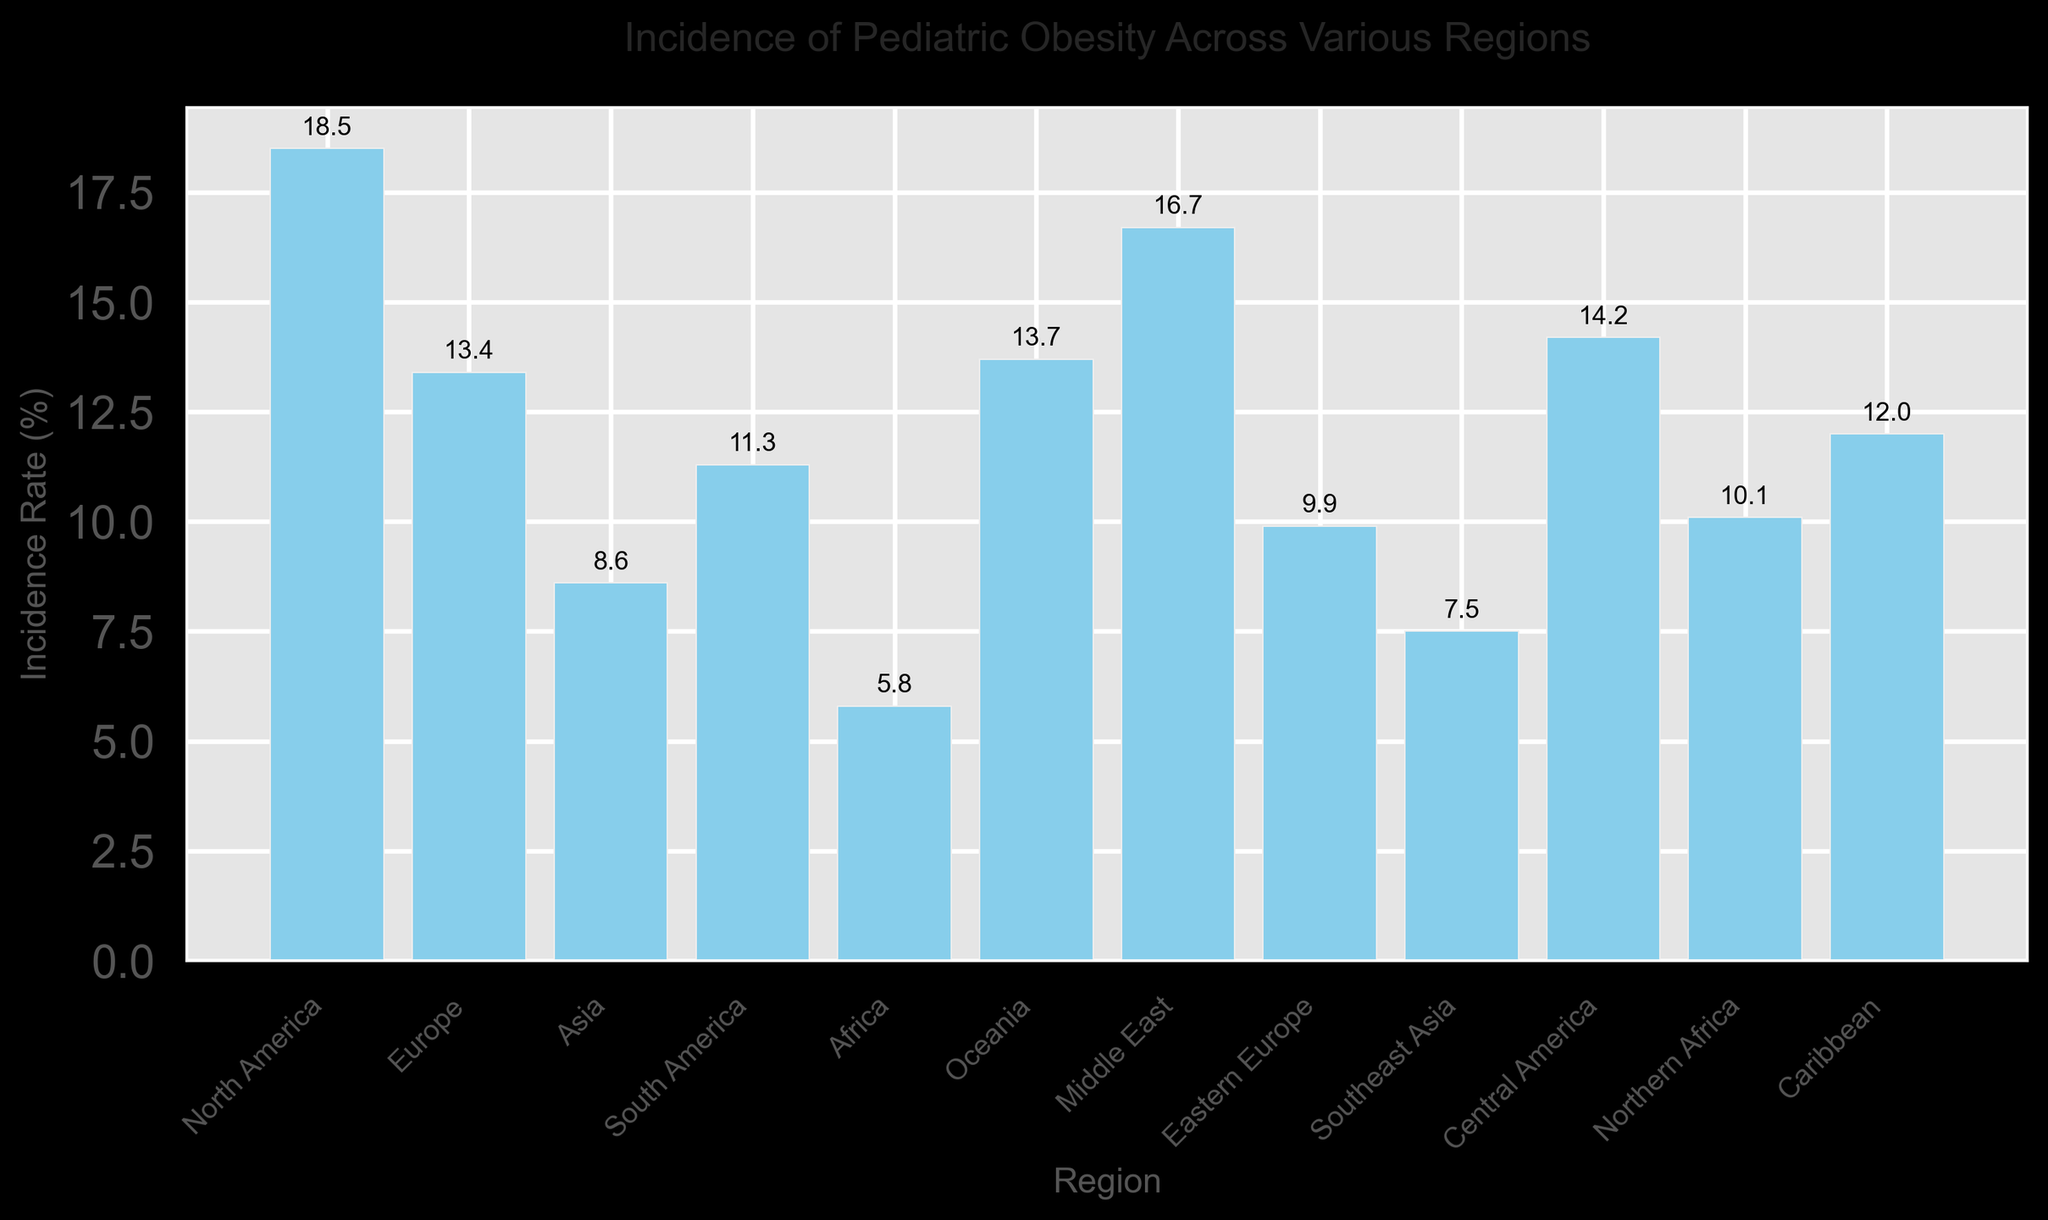What region has the highest incidence rate of pediatric obesity? To find the region with the highest incidence rate, look for the tallest bar in the bar chart. The label underneath the tallest bar represents the region with the highest incidence rate.
Answer: North America Which regions have an incidence rate of pediatric obesity greater than 15%? Identify the bars that extend above the 15% mark on the y-axis. Note the labels of those bars to determine the regions.
Answer: North America, Middle East How many regions have an incidence rate of pediatric obesity less than 10%? Count the number of bars that are shorter than the 10% mark on the y-axis.
Answer: 5 What is the difference in incidence rate between North America and Europe? Subtract the incidence rate of Europe from the incidence rate of North America using the bar heights. North America is 18.5% and Europe is 13.4%. The difference is: 18.5% - 13.4% = 5.1%.
Answer: 5.1% What is the average incidence rate of pediatric obesity for Asia, Southeast Asia, and Africa? Add the incidence rates for Asia (8.6%), Southeast Asia (7.5%), and Africa (5.8%) and divide by the number of regions (3). Calculation: (8.6 + 7.5 + 5.8) / 3 = 7.3%.
Answer: 7.3% Which region has a higher incidence rate, Central America or Northern Africa, and by how much? Compare the heights of the bars for Central America and Northern Africa. Central America has an incidence rate of 14.2%, and Northern Africa has 10.1%. The difference is: 14.2% - 10.1% = 4.1%.
Answer: Central America, by 4.1% Which region has the second-lowest incidence rate of pediatric obesity? Identify the bar that is just above the shortest bar. The shortest bar corresponds to Africa with 5.8%, and the bar just above it is Southeast Asia with 7.5%.
Answer: Southeast Asia How does the incidence rate of the Caribbean compare to that of South America? Compare the heights of the bars for the Caribbean and South America. The Caribbean has an incidence rate of 12.0%, while South America has 11.3%. The Caribbean's rate is higher.
Answer: Caribbean is higher What's the combined incidence rate of pediatric obesity for Europe, Oceania, and the Middle East? Add the incidence rates for Europe (13.4%), Oceania (13.7%), and the Middle East (16.7%). Calculation: 13.4% + 13.7% + 16.7% = 43.8%.
Answer: 43.8% What is the median incidence rate of pediatric obesity across all regions? List the incidence rates in ascending order: 5.8%, 7.5%, 8.6%, 9.9%, 10.1%, 11.3%, 12.0%, 13.4%, 13.7%, 14.2%, 16.7%, 18.5%. Find the middle values (10.1 and 11.3) and calculate their average: (10.1 + 11.3) / 2 = 10.7%.
Answer: 10.7% 